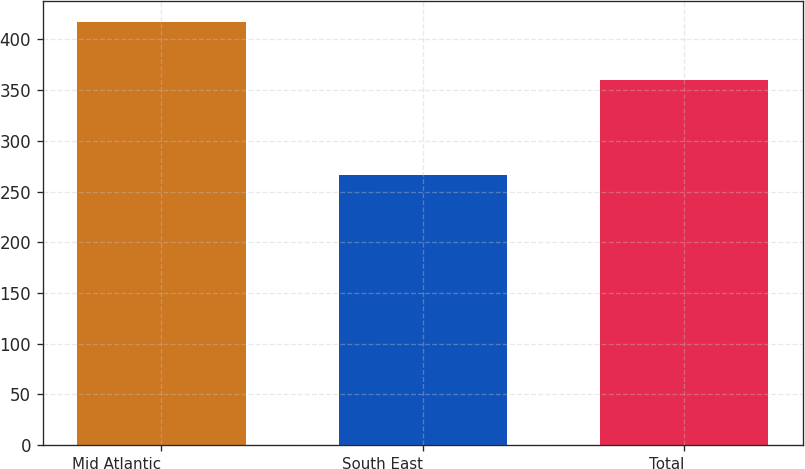Convert chart. <chart><loc_0><loc_0><loc_500><loc_500><bar_chart><fcel>Mid Atlantic<fcel>South East<fcel>Total<nl><fcel>416.7<fcel>265.9<fcel>360.4<nl></chart> 